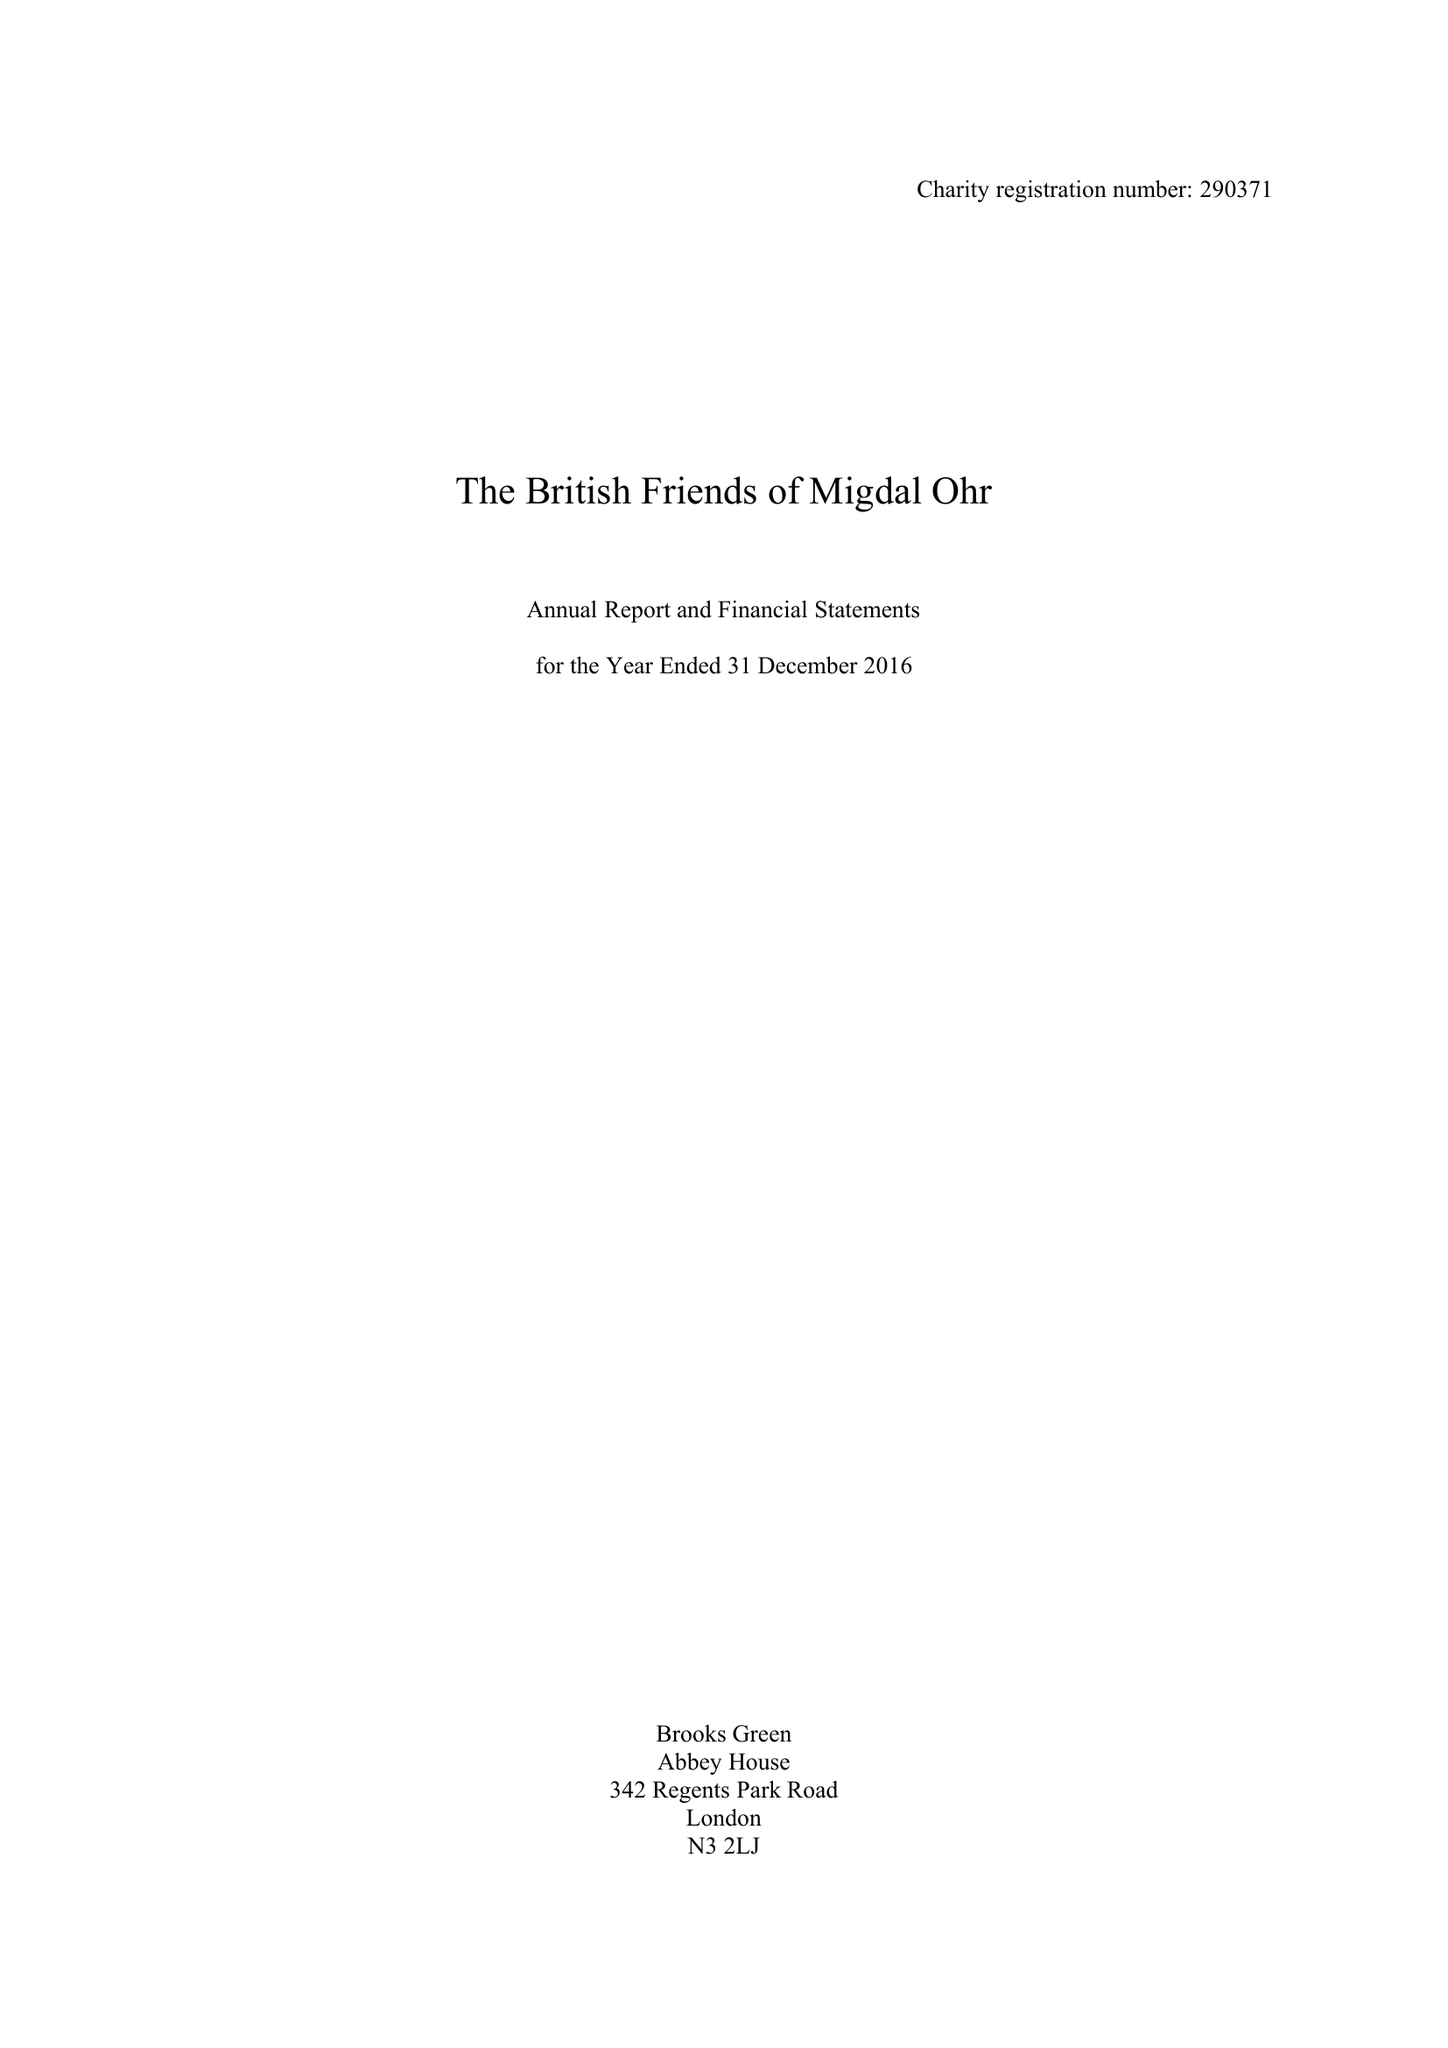What is the value for the address__post_town?
Answer the question using a single word or phrase. LONDON 